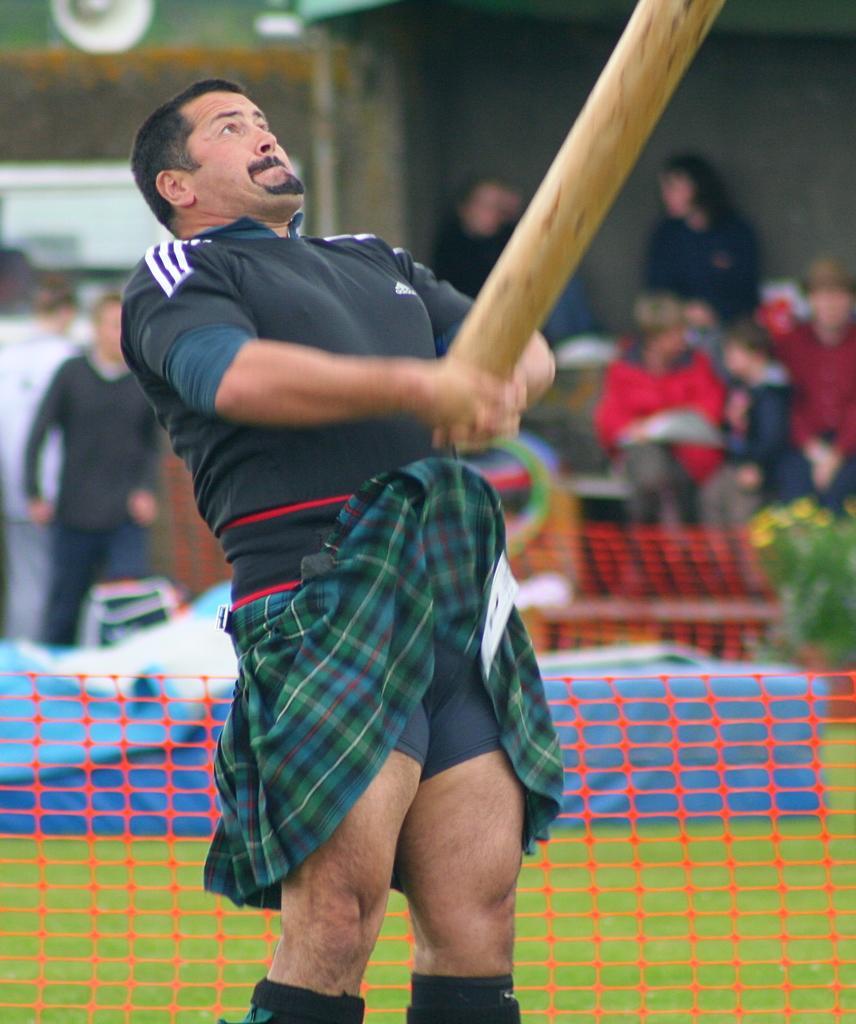Describe this image in one or two sentences. In the center of the image we can see a man holding the wooden object. We can also see the fence and behind the fence we can see the ground, plant, people and also the wall. 